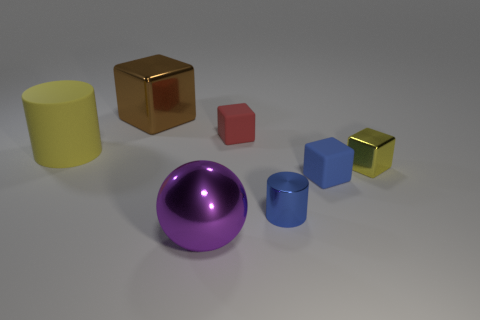How many other objects are there of the same color as the rubber cylinder?
Your answer should be very brief. 1. What number of other objects are the same shape as the red rubber thing?
Your response must be concise. 3. Are there the same number of tiny shiny cubes left of the small shiny cylinder and small blue metal cylinders that are on the left side of the big brown cube?
Ensure brevity in your answer.  Yes. Are there any brown blocks that have the same material as the brown thing?
Offer a very short reply. No. Is the material of the tiny yellow cube the same as the brown cube?
Your answer should be compact. Yes. How many blue objects are either tiny things or large shiny balls?
Provide a succinct answer. 2. Are there more purple shiny things behind the large rubber cylinder than red cylinders?
Offer a terse response. No. Are there any other shiny spheres of the same color as the shiny ball?
Your answer should be compact. No. How big is the brown block?
Offer a terse response. Large. Is the color of the tiny shiny block the same as the big shiny ball?
Your answer should be compact. No. 